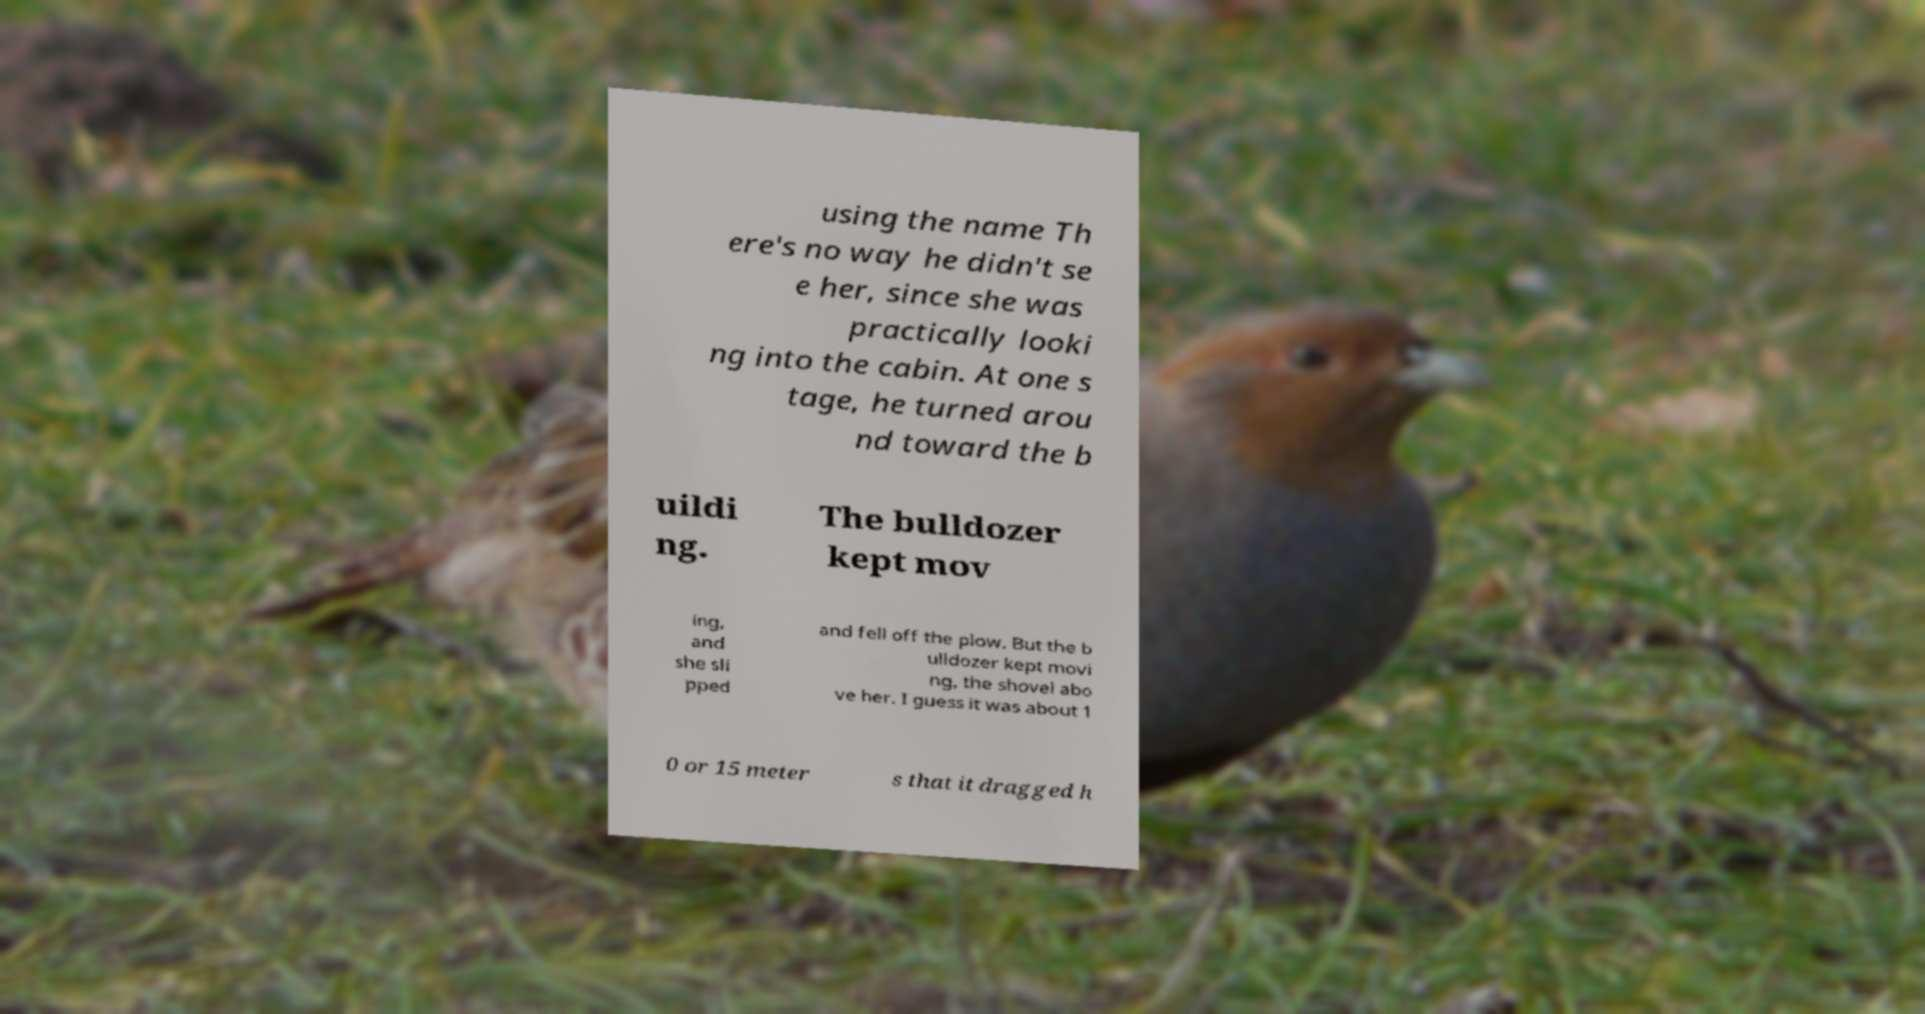Could you extract and type out the text from this image? using the name Th ere's no way he didn't se e her, since she was practically looki ng into the cabin. At one s tage, he turned arou nd toward the b uildi ng. The bulldozer kept mov ing, and she sli pped and fell off the plow. But the b ulldozer kept movi ng, the shovel abo ve her. I guess it was about 1 0 or 15 meter s that it dragged h 